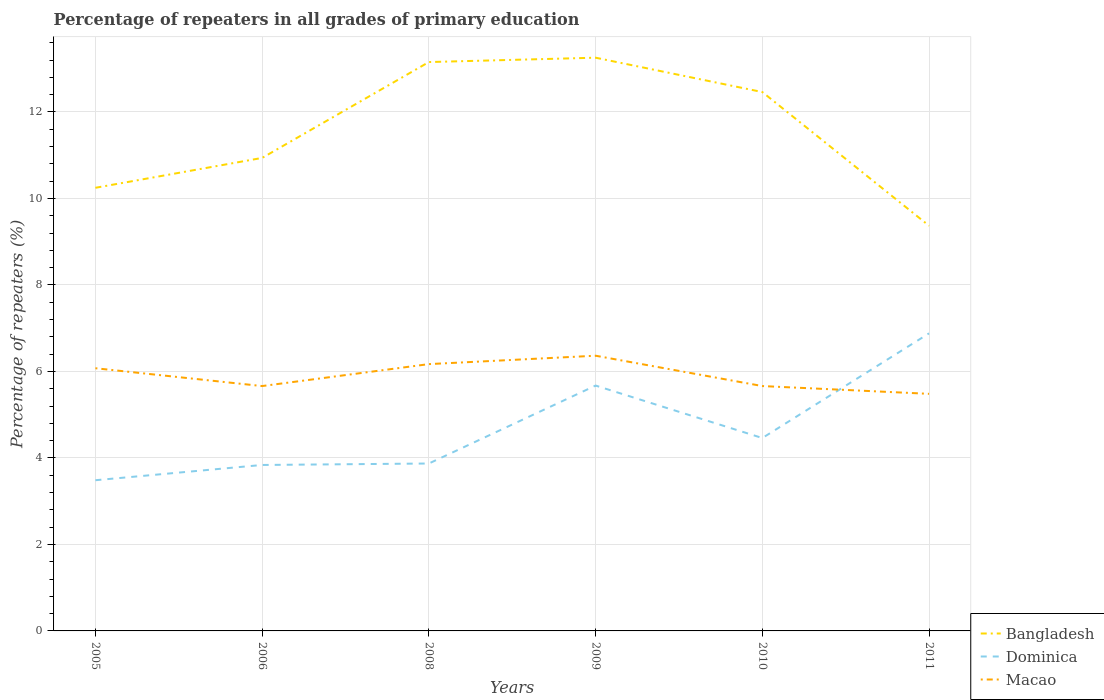Does the line corresponding to Macao intersect with the line corresponding to Bangladesh?
Make the answer very short. No. Is the number of lines equal to the number of legend labels?
Offer a very short reply. Yes. Across all years, what is the maximum percentage of repeaters in Dominica?
Make the answer very short. 3.48. What is the total percentage of repeaters in Dominica in the graph?
Give a very brief answer. -0.62. What is the difference between the highest and the second highest percentage of repeaters in Dominica?
Your response must be concise. 3.4. What is the difference between two consecutive major ticks on the Y-axis?
Provide a succinct answer. 2. Does the graph contain any zero values?
Your answer should be very brief. No. How many legend labels are there?
Provide a succinct answer. 3. What is the title of the graph?
Give a very brief answer. Percentage of repeaters in all grades of primary education. What is the label or title of the X-axis?
Provide a succinct answer. Years. What is the label or title of the Y-axis?
Keep it short and to the point. Percentage of repeaters (%). What is the Percentage of repeaters (%) of Bangladesh in 2005?
Make the answer very short. 10.25. What is the Percentage of repeaters (%) of Dominica in 2005?
Give a very brief answer. 3.48. What is the Percentage of repeaters (%) in Macao in 2005?
Your response must be concise. 6.07. What is the Percentage of repeaters (%) in Bangladesh in 2006?
Provide a short and direct response. 10.94. What is the Percentage of repeaters (%) in Dominica in 2006?
Your response must be concise. 3.84. What is the Percentage of repeaters (%) in Macao in 2006?
Your answer should be very brief. 5.66. What is the Percentage of repeaters (%) of Bangladesh in 2008?
Your answer should be very brief. 13.15. What is the Percentage of repeaters (%) in Dominica in 2008?
Offer a terse response. 3.87. What is the Percentage of repeaters (%) of Macao in 2008?
Provide a short and direct response. 6.17. What is the Percentage of repeaters (%) in Bangladesh in 2009?
Ensure brevity in your answer.  13.26. What is the Percentage of repeaters (%) in Dominica in 2009?
Provide a succinct answer. 5.67. What is the Percentage of repeaters (%) of Macao in 2009?
Keep it short and to the point. 6.36. What is the Percentage of repeaters (%) in Bangladesh in 2010?
Ensure brevity in your answer.  12.46. What is the Percentage of repeaters (%) in Dominica in 2010?
Give a very brief answer. 4.46. What is the Percentage of repeaters (%) of Macao in 2010?
Your response must be concise. 5.66. What is the Percentage of repeaters (%) of Bangladesh in 2011?
Offer a very short reply. 9.37. What is the Percentage of repeaters (%) of Dominica in 2011?
Make the answer very short. 6.88. What is the Percentage of repeaters (%) in Macao in 2011?
Your answer should be very brief. 5.48. Across all years, what is the maximum Percentage of repeaters (%) in Bangladesh?
Your answer should be compact. 13.26. Across all years, what is the maximum Percentage of repeaters (%) of Dominica?
Offer a terse response. 6.88. Across all years, what is the maximum Percentage of repeaters (%) in Macao?
Your answer should be compact. 6.36. Across all years, what is the minimum Percentage of repeaters (%) in Bangladesh?
Provide a succinct answer. 9.37. Across all years, what is the minimum Percentage of repeaters (%) in Dominica?
Keep it short and to the point. 3.48. Across all years, what is the minimum Percentage of repeaters (%) of Macao?
Provide a short and direct response. 5.48. What is the total Percentage of repeaters (%) of Bangladesh in the graph?
Your answer should be very brief. 69.43. What is the total Percentage of repeaters (%) in Dominica in the graph?
Offer a very short reply. 28.21. What is the total Percentage of repeaters (%) in Macao in the graph?
Give a very brief answer. 35.42. What is the difference between the Percentage of repeaters (%) in Bangladesh in 2005 and that in 2006?
Your response must be concise. -0.69. What is the difference between the Percentage of repeaters (%) of Dominica in 2005 and that in 2006?
Offer a very short reply. -0.35. What is the difference between the Percentage of repeaters (%) of Macao in 2005 and that in 2006?
Provide a succinct answer. 0.41. What is the difference between the Percentage of repeaters (%) of Bangladesh in 2005 and that in 2008?
Offer a very short reply. -2.91. What is the difference between the Percentage of repeaters (%) of Dominica in 2005 and that in 2008?
Provide a succinct answer. -0.39. What is the difference between the Percentage of repeaters (%) of Macao in 2005 and that in 2008?
Offer a very short reply. -0.1. What is the difference between the Percentage of repeaters (%) of Bangladesh in 2005 and that in 2009?
Your answer should be very brief. -3.01. What is the difference between the Percentage of repeaters (%) in Dominica in 2005 and that in 2009?
Make the answer very short. -2.19. What is the difference between the Percentage of repeaters (%) in Macao in 2005 and that in 2009?
Make the answer very short. -0.29. What is the difference between the Percentage of repeaters (%) of Bangladesh in 2005 and that in 2010?
Give a very brief answer. -2.21. What is the difference between the Percentage of repeaters (%) of Dominica in 2005 and that in 2010?
Make the answer very short. -0.98. What is the difference between the Percentage of repeaters (%) in Macao in 2005 and that in 2010?
Provide a succinct answer. 0.41. What is the difference between the Percentage of repeaters (%) in Bangladesh in 2005 and that in 2011?
Your response must be concise. 0.88. What is the difference between the Percentage of repeaters (%) of Dominica in 2005 and that in 2011?
Make the answer very short. -3.4. What is the difference between the Percentage of repeaters (%) in Macao in 2005 and that in 2011?
Your answer should be compact. 0.59. What is the difference between the Percentage of repeaters (%) in Bangladesh in 2006 and that in 2008?
Offer a terse response. -2.22. What is the difference between the Percentage of repeaters (%) of Dominica in 2006 and that in 2008?
Your answer should be compact. -0.03. What is the difference between the Percentage of repeaters (%) in Macao in 2006 and that in 2008?
Offer a very short reply. -0.51. What is the difference between the Percentage of repeaters (%) in Bangladesh in 2006 and that in 2009?
Your response must be concise. -2.32. What is the difference between the Percentage of repeaters (%) in Dominica in 2006 and that in 2009?
Provide a short and direct response. -1.84. What is the difference between the Percentage of repeaters (%) in Macao in 2006 and that in 2009?
Provide a short and direct response. -0.7. What is the difference between the Percentage of repeaters (%) in Bangladesh in 2006 and that in 2010?
Your response must be concise. -1.52. What is the difference between the Percentage of repeaters (%) of Dominica in 2006 and that in 2010?
Your answer should be compact. -0.62. What is the difference between the Percentage of repeaters (%) of Macao in 2006 and that in 2010?
Provide a short and direct response. 0. What is the difference between the Percentage of repeaters (%) in Bangladesh in 2006 and that in 2011?
Keep it short and to the point. 1.57. What is the difference between the Percentage of repeaters (%) of Dominica in 2006 and that in 2011?
Offer a very short reply. -3.04. What is the difference between the Percentage of repeaters (%) of Macao in 2006 and that in 2011?
Offer a very short reply. 0.18. What is the difference between the Percentage of repeaters (%) of Bangladesh in 2008 and that in 2009?
Make the answer very short. -0.1. What is the difference between the Percentage of repeaters (%) in Dominica in 2008 and that in 2009?
Provide a short and direct response. -1.8. What is the difference between the Percentage of repeaters (%) of Macao in 2008 and that in 2009?
Make the answer very short. -0.19. What is the difference between the Percentage of repeaters (%) of Bangladesh in 2008 and that in 2010?
Your answer should be compact. 0.69. What is the difference between the Percentage of repeaters (%) of Dominica in 2008 and that in 2010?
Make the answer very short. -0.59. What is the difference between the Percentage of repeaters (%) of Macao in 2008 and that in 2010?
Your response must be concise. 0.51. What is the difference between the Percentage of repeaters (%) of Bangladesh in 2008 and that in 2011?
Ensure brevity in your answer.  3.79. What is the difference between the Percentage of repeaters (%) of Dominica in 2008 and that in 2011?
Provide a succinct answer. -3.01. What is the difference between the Percentage of repeaters (%) of Macao in 2008 and that in 2011?
Provide a succinct answer. 0.69. What is the difference between the Percentage of repeaters (%) of Bangladesh in 2009 and that in 2010?
Provide a succinct answer. 0.79. What is the difference between the Percentage of repeaters (%) in Dominica in 2009 and that in 2010?
Your response must be concise. 1.21. What is the difference between the Percentage of repeaters (%) in Macao in 2009 and that in 2010?
Make the answer very short. 0.7. What is the difference between the Percentage of repeaters (%) in Bangladesh in 2009 and that in 2011?
Keep it short and to the point. 3.89. What is the difference between the Percentage of repeaters (%) of Dominica in 2009 and that in 2011?
Your answer should be compact. -1.21. What is the difference between the Percentage of repeaters (%) of Macao in 2009 and that in 2011?
Provide a succinct answer. 0.88. What is the difference between the Percentage of repeaters (%) in Bangladesh in 2010 and that in 2011?
Give a very brief answer. 3.09. What is the difference between the Percentage of repeaters (%) of Dominica in 2010 and that in 2011?
Ensure brevity in your answer.  -2.42. What is the difference between the Percentage of repeaters (%) of Macao in 2010 and that in 2011?
Your answer should be very brief. 0.18. What is the difference between the Percentage of repeaters (%) in Bangladesh in 2005 and the Percentage of repeaters (%) in Dominica in 2006?
Your answer should be compact. 6.41. What is the difference between the Percentage of repeaters (%) of Bangladesh in 2005 and the Percentage of repeaters (%) of Macao in 2006?
Offer a terse response. 4.58. What is the difference between the Percentage of repeaters (%) in Dominica in 2005 and the Percentage of repeaters (%) in Macao in 2006?
Give a very brief answer. -2.18. What is the difference between the Percentage of repeaters (%) of Bangladesh in 2005 and the Percentage of repeaters (%) of Dominica in 2008?
Your answer should be compact. 6.38. What is the difference between the Percentage of repeaters (%) in Bangladesh in 2005 and the Percentage of repeaters (%) in Macao in 2008?
Give a very brief answer. 4.08. What is the difference between the Percentage of repeaters (%) of Dominica in 2005 and the Percentage of repeaters (%) of Macao in 2008?
Give a very brief answer. -2.69. What is the difference between the Percentage of repeaters (%) in Bangladesh in 2005 and the Percentage of repeaters (%) in Dominica in 2009?
Keep it short and to the point. 4.57. What is the difference between the Percentage of repeaters (%) in Bangladesh in 2005 and the Percentage of repeaters (%) in Macao in 2009?
Offer a very short reply. 3.88. What is the difference between the Percentage of repeaters (%) in Dominica in 2005 and the Percentage of repeaters (%) in Macao in 2009?
Make the answer very short. -2.88. What is the difference between the Percentage of repeaters (%) of Bangladesh in 2005 and the Percentage of repeaters (%) of Dominica in 2010?
Keep it short and to the point. 5.79. What is the difference between the Percentage of repeaters (%) in Bangladesh in 2005 and the Percentage of repeaters (%) in Macao in 2010?
Offer a terse response. 4.58. What is the difference between the Percentage of repeaters (%) of Dominica in 2005 and the Percentage of repeaters (%) of Macao in 2010?
Make the answer very short. -2.18. What is the difference between the Percentage of repeaters (%) of Bangladesh in 2005 and the Percentage of repeaters (%) of Dominica in 2011?
Keep it short and to the point. 3.37. What is the difference between the Percentage of repeaters (%) in Bangladesh in 2005 and the Percentage of repeaters (%) in Macao in 2011?
Keep it short and to the point. 4.76. What is the difference between the Percentage of repeaters (%) in Dominica in 2005 and the Percentage of repeaters (%) in Macao in 2011?
Give a very brief answer. -2. What is the difference between the Percentage of repeaters (%) of Bangladesh in 2006 and the Percentage of repeaters (%) of Dominica in 2008?
Ensure brevity in your answer.  7.07. What is the difference between the Percentage of repeaters (%) in Bangladesh in 2006 and the Percentage of repeaters (%) in Macao in 2008?
Keep it short and to the point. 4.77. What is the difference between the Percentage of repeaters (%) of Dominica in 2006 and the Percentage of repeaters (%) of Macao in 2008?
Provide a succinct answer. -2.33. What is the difference between the Percentage of repeaters (%) in Bangladesh in 2006 and the Percentage of repeaters (%) in Dominica in 2009?
Provide a short and direct response. 5.26. What is the difference between the Percentage of repeaters (%) in Bangladesh in 2006 and the Percentage of repeaters (%) in Macao in 2009?
Offer a terse response. 4.57. What is the difference between the Percentage of repeaters (%) of Dominica in 2006 and the Percentage of repeaters (%) of Macao in 2009?
Provide a short and direct response. -2.53. What is the difference between the Percentage of repeaters (%) of Bangladesh in 2006 and the Percentage of repeaters (%) of Dominica in 2010?
Make the answer very short. 6.48. What is the difference between the Percentage of repeaters (%) of Bangladesh in 2006 and the Percentage of repeaters (%) of Macao in 2010?
Your answer should be very brief. 5.28. What is the difference between the Percentage of repeaters (%) in Dominica in 2006 and the Percentage of repeaters (%) in Macao in 2010?
Your response must be concise. -1.82. What is the difference between the Percentage of repeaters (%) of Bangladesh in 2006 and the Percentage of repeaters (%) of Dominica in 2011?
Your answer should be compact. 4.06. What is the difference between the Percentage of repeaters (%) of Bangladesh in 2006 and the Percentage of repeaters (%) of Macao in 2011?
Your answer should be very brief. 5.46. What is the difference between the Percentage of repeaters (%) in Dominica in 2006 and the Percentage of repeaters (%) in Macao in 2011?
Offer a terse response. -1.64. What is the difference between the Percentage of repeaters (%) of Bangladesh in 2008 and the Percentage of repeaters (%) of Dominica in 2009?
Ensure brevity in your answer.  7.48. What is the difference between the Percentage of repeaters (%) of Bangladesh in 2008 and the Percentage of repeaters (%) of Macao in 2009?
Your answer should be compact. 6.79. What is the difference between the Percentage of repeaters (%) of Dominica in 2008 and the Percentage of repeaters (%) of Macao in 2009?
Provide a succinct answer. -2.49. What is the difference between the Percentage of repeaters (%) of Bangladesh in 2008 and the Percentage of repeaters (%) of Dominica in 2010?
Your answer should be very brief. 8.69. What is the difference between the Percentage of repeaters (%) in Bangladesh in 2008 and the Percentage of repeaters (%) in Macao in 2010?
Ensure brevity in your answer.  7.49. What is the difference between the Percentage of repeaters (%) of Dominica in 2008 and the Percentage of repeaters (%) of Macao in 2010?
Your answer should be very brief. -1.79. What is the difference between the Percentage of repeaters (%) of Bangladesh in 2008 and the Percentage of repeaters (%) of Dominica in 2011?
Give a very brief answer. 6.27. What is the difference between the Percentage of repeaters (%) of Bangladesh in 2008 and the Percentage of repeaters (%) of Macao in 2011?
Your answer should be very brief. 7.67. What is the difference between the Percentage of repeaters (%) of Dominica in 2008 and the Percentage of repeaters (%) of Macao in 2011?
Make the answer very short. -1.61. What is the difference between the Percentage of repeaters (%) in Bangladesh in 2009 and the Percentage of repeaters (%) in Dominica in 2010?
Provide a short and direct response. 8.79. What is the difference between the Percentage of repeaters (%) in Bangladesh in 2009 and the Percentage of repeaters (%) in Macao in 2010?
Provide a short and direct response. 7.59. What is the difference between the Percentage of repeaters (%) in Dominica in 2009 and the Percentage of repeaters (%) in Macao in 2010?
Give a very brief answer. 0.01. What is the difference between the Percentage of repeaters (%) in Bangladesh in 2009 and the Percentage of repeaters (%) in Dominica in 2011?
Give a very brief answer. 6.37. What is the difference between the Percentage of repeaters (%) in Bangladesh in 2009 and the Percentage of repeaters (%) in Macao in 2011?
Keep it short and to the point. 7.77. What is the difference between the Percentage of repeaters (%) of Dominica in 2009 and the Percentage of repeaters (%) of Macao in 2011?
Offer a very short reply. 0.19. What is the difference between the Percentage of repeaters (%) in Bangladesh in 2010 and the Percentage of repeaters (%) in Dominica in 2011?
Your answer should be compact. 5.58. What is the difference between the Percentage of repeaters (%) in Bangladesh in 2010 and the Percentage of repeaters (%) in Macao in 2011?
Provide a succinct answer. 6.98. What is the difference between the Percentage of repeaters (%) in Dominica in 2010 and the Percentage of repeaters (%) in Macao in 2011?
Provide a short and direct response. -1.02. What is the average Percentage of repeaters (%) of Bangladesh per year?
Provide a short and direct response. 11.57. What is the average Percentage of repeaters (%) in Dominica per year?
Make the answer very short. 4.7. What is the average Percentage of repeaters (%) of Macao per year?
Provide a succinct answer. 5.9. In the year 2005, what is the difference between the Percentage of repeaters (%) of Bangladesh and Percentage of repeaters (%) of Dominica?
Give a very brief answer. 6.76. In the year 2005, what is the difference between the Percentage of repeaters (%) in Bangladesh and Percentage of repeaters (%) in Macao?
Your answer should be compact. 4.17. In the year 2005, what is the difference between the Percentage of repeaters (%) in Dominica and Percentage of repeaters (%) in Macao?
Give a very brief answer. -2.59. In the year 2006, what is the difference between the Percentage of repeaters (%) of Bangladesh and Percentage of repeaters (%) of Dominica?
Keep it short and to the point. 7.1. In the year 2006, what is the difference between the Percentage of repeaters (%) of Bangladesh and Percentage of repeaters (%) of Macao?
Your response must be concise. 5.28. In the year 2006, what is the difference between the Percentage of repeaters (%) of Dominica and Percentage of repeaters (%) of Macao?
Your answer should be very brief. -1.82. In the year 2008, what is the difference between the Percentage of repeaters (%) of Bangladesh and Percentage of repeaters (%) of Dominica?
Ensure brevity in your answer.  9.28. In the year 2008, what is the difference between the Percentage of repeaters (%) in Bangladesh and Percentage of repeaters (%) in Macao?
Keep it short and to the point. 6.98. In the year 2008, what is the difference between the Percentage of repeaters (%) of Dominica and Percentage of repeaters (%) of Macao?
Ensure brevity in your answer.  -2.3. In the year 2009, what is the difference between the Percentage of repeaters (%) in Bangladesh and Percentage of repeaters (%) in Dominica?
Provide a succinct answer. 7.58. In the year 2009, what is the difference between the Percentage of repeaters (%) of Bangladesh and Percentage of repeaters (%) of Macao?
Offer a very short reply. 6.89. In the year 2009, what is the difference between the Percentage of repeaters (%) in Dominica and Percentage of repeaters (%) in Macao?
Offer a terse response. -0.69. In the year 2010, what is the difference between the Percentage of repeaters (%) in Bangladesh and Percentage of repeaters (%) in Dominica?
Keep it short and to the point. 8. In the year 2010, what is the difference between the Percentage of repeaters (%) in Bangladesh and Percentage of repeaters (%) in Macao?
Provide a succinct answer. 6.8. In the year 2010, what is the difference between the Percentage of repeaters (%) of Dominica and Percentage of repeaters (%) of Macao?
Your answer should be compact. -1.2. In the year 2011, what is the difference between the Percentage of repeaters (%) in Bangladesh and Percentage of repeaters (%) in Dominica?
Ensure brevity in your answer.  2.49. In the year 2011, what is the difference between the Percentage of repeaters (%) of Bangladesh and Percentage of repeaters (%) of Macao?
Offer a very short reply. 3.89. In the year 2011, what is the difference between the Percentage of repeaters (%) in Dominica and Percentage of repeaters (%) in Macao?
Offer a very short reply. 1.4. What is the ratio of the Percentage of repeaters (%) of Bangladesh in 2005 to that in 2006?
Offer a very short reply. 0.94. What is the ratio of the Percentage of repeaters (%) in Dominica in 2005 to that in 2006?
Provide a short and direct response. 0.91. What is the ratio of the Percentage of repeaters (%) in Macao in 2005 to that in 2006?
Give a very brief answer. 1.07. What is the ratio of the Percentage of repeaters (%) of Bangladesh in 2005 to that in 2008?
Your answer should be very brief. 0.78. What is the ratio of the Percentage of repeaters (%) of Dominica in 2005 to that in 2008?
Make the answer very short. 0.9. What is the ratio of the Percentage of repeaters (%) of Macao in 2005 to that in 2008?
Your response must be concise. 0.98. What is the ratio of the Percentage of repeaters (%) in Bangladesh in 2005 to that in 2009?
Keep it short and to the point. 0.77. What is the ratio of the Percentage of repeaters (%) in Dominica in 2005 to that in 2009?
Provide a succinct answer. 0.61. What is the ratio of the Percentage of repeaters (%) in Macao in 2005 to that in 2009?
Your answer should be compact. 0.95. What is the ratio of the Percentage of repeaters (%) in Bangladesh in 2005 to that in 2010?
Offer a very short reply. 0.82. What is the ratio of the Percentage of repeaters (%) in Dominica in 2005 to that in 2010?
Give a very brief answer. 0.78. What is the ratio of the Percentage of repeaters (%) of Macao in 2005 to that in 2010?
Make the answer very short. 1.07. What is the ratio of the Percentage of repeaters (%) of Bangladesh in 2005 to that in 2011?
Keep it short and to the point. 1.09. What is the ratio of the Percentage of repeaters (%) of Dominica in 2005 to that in 2011?
Offer a terse response. 0.51. What is the ratio of the Percentage of repeaters (%) of Macao in 2005 to that in 2011?
Give a very brief answer. 1.11. What is the ratio of the Percentage of repeaters (%) of Bangladesh in 2006 to that in 2008?
Offer a very short reply. 0.83. What is the ratio of the Percentage of repeaters (%) of Macao in 2006 to that in 2008?
Offer a very short reply. 0.92. What is the ratio of the Percentage of repeaters (%) of Bangladesh in 2006 to that in 2009?
Your answer should be very brief. 0.83. What is the ratio of the Percentage of repeaters (%) in Dominica in 2006 to that in 2009?
Your response must be concise. 0.68. What is the ratio of the Percentage of repeaters (%) of Macao in 2006 to that in 2009?
Provide a succinct answer. 0.89. What is the ratio of the Percentage of repeaters (%) in Bangladesh in 2006 to that in 2010?
Your answer should be very brief. 0.88. What is the ratio of the Percentage of repeaters (%) in Dominica in 2006 to that in 2010?
Make the answer very short. 0.86. What is the ratio of the Percentage of repeaters (%) of Macao in 2006 to that in 2010?
Your answer should be compact. 1. What is the ratio of the Percentage of repeaters (%) in Bangladesh in 2006 to that in 2011?
Ensure brevity in your answer.  1.17. What is the ratio of the Percentage of repeaters (%) of Dominica in 2006 to that in 2011?
Your answer should be compact. 0.56. What is the ratio of the Percentage of repeaters (%) in Macao in 2006 to that in 2011?
Your answer should be very brief. 1.03. What is the ratio of the Percentage of repeaters (%) of Bangladesh in 2008 to that in 2009?
Keep it short and to the point. 0.99. What is the ratio of the Percentage of repeaters (%) in Dominica in 2008 to that in 2009?
Your response must be concise. 0.68. What is the ratio of the Percentage of repeaters (%) of Macao in 2008 to that in 2009?
Your response must be concise. 0.97. What is the ratio of the Percentage of repeaters (%) of Bangladesh in 2008 to that in 2010?
Give a very brief answer. 1.06. What is the ratio of the Percentage of repeaters (%) in Dominica in 2008 to that in 2010?
Keep it short and to the point. 0.87. What is the ratio of the Percentage of repeaters (%) in Macao in 2008 to that in 2010?
Your answer should be very brief. 1.09. What is the ratio of the Percentage of repeaters (%) of Bangladesh in 2008 to that in 2011?
Your response must be concise. 1.4. What is the ratio of the Percentage of repeaters (%) of Dominica in 2008 to that in 2011?
Keep it short and to the point. 0.56. What is the ratio of the Percentage of repeaters (%) of Macao in 2008 to that in 2011?
Give a very brief answer. 1.13. What is the ratio of the Percentage of repeaters (%) in Bangladesh in 2009 to that in 2010?
Your answer should be compact. 1.06. What is the ratio of the Percentage of repeaters (%) of Dominica in 2009 to that in 2010?
Keep it short and to the point. 1.27. What is the ratio of the Percentage of repeaters (%) in Macao in 2009 to that in 2010?
Keep it short and to the point. 1.12. What is the ratio of the Percentage of repeaters (%) in Bangladesh in 2009 to that in 2011?
Offer a very short reply. 1.41. What is the ratio of the Percentage of repeaters (%) of Dominica in 2009 to that in 2011?
Make the answer very short. 0.82. What is the ratio of the Percentage of repeaters (%) of Macao in 2009 to that in 2011?
Give a very brief answer. 1.16. What is the ratio of the Percentage of repeaters (%) of Bangladesh in 2010 to that in 2011?
Provide a short and direct response. 1.33. What is the ratio of the Percentage of repeaters (%) of Dominica in 2010 to that in 2011?
Your answer should be compact. 0.65. What is the ratio of the Percentage of repeaters (%) of Macao in 2010 to that in 2011?
Give a very brief answer. 1.03. What is the difference between the highest and the second highest Percentage of repeaters (%) in Bangladesh?
Keep it short and to the point. 0.1. What is the difference between the highest and the second highest Percentage of repeaters (%) of Dominica?
Ensure brevity in your answer.  1.21. What is the difference between the highest and the second highest Percentage of repeaters (%) of Macao?
Keep it short and to the point. 0.19. What is the difference between the highest and the lowest Percentage of repeaters (%) of Bangladesh?
Keep it short and to the point. 3.89. What is the difference between the highest and the lowest Percentage of repeaters (%) in Dominica?
Keep it short and to the point. 3.4. What is the difference between the highest and the lowest Percentage of repeaters (%) in Macao?
Provide a short and direct response. 0.88. 